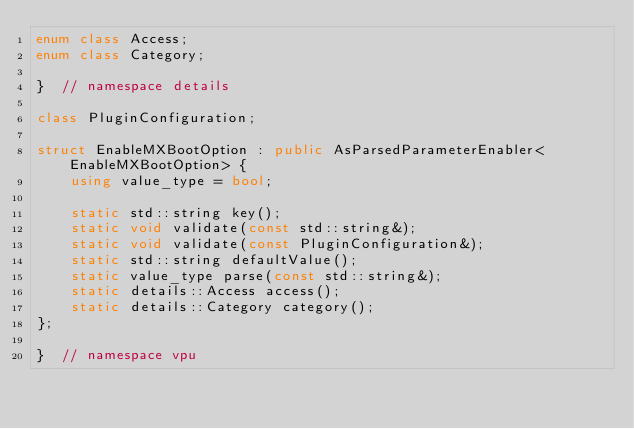<code> <loc_0><loc_0><loc_500><loc_500><_C++_>enum class Access;
enum class Category;

}  // namespace details

class PluginConfiguration;

struct EnableMXBootOption : public AsParsedParameterEnabler<EnableMXBootOption> {
    using value_type = bool;

    static std::string key();
    static void validate(const std::string&);
    static void validate(const PluginConfiguration&);
    static std::string defaultValue();
    static value_type parse(const std::string&);
    static details::Access access();
    static details::Category category();
};

}  // namespace vpu
</code> 